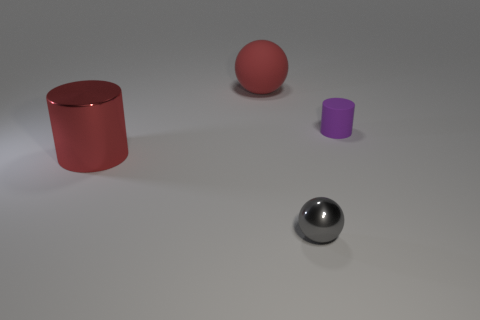What number of things are big matte balls or cylinders that are behind the large metal thing?
Offer a very short reply. 2. What size is the thing that is both on the left side of the gray sphere and in front of the large rubber ball?
Keep it short and to the point. Large. Are there more tiny gray objects that are right of the tiny metallic object than large red cylinders that are in front of the large cylinder?
Your answer should be compact. No. There is a tiny gray thing; does it have the same shape as the metal thing that is behind the metal sphere?
Offer a terse response. No. How many other objects are there of the same shape as the red metal thing?
Your answer should be very brief. 1. There is a object that is in front of the small rubber object and to the right of the large cylinder; what color is it?
Offer a very short reply. Gray. The big sphere has what color?
Ensure brevity in your answer.  Red. Does the tiny purple cylinder have the same material as the red object that is behind the tiny matte cylinder?
Provide a succinct answer. Yes. The big red object that is made of the same material as the tiny purple thing is what shape?
Provide a short and direct response. Sphere. There is a shiny thing that is the same size as the purple cylinder; what color is it?
Provide a short and direct response. Gray. 